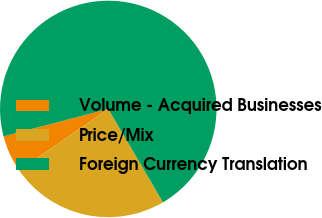<chart> <loc_0><loc_0><loc_500><loc_500><pie_chart><fcel>Volume - Acquired Businesses<fcel>Price/Mix<fcel>Foreign Currency Translation<nl><fcel>5.54%<fcel>23.81%<fcel>70.65%<nl></chart> 